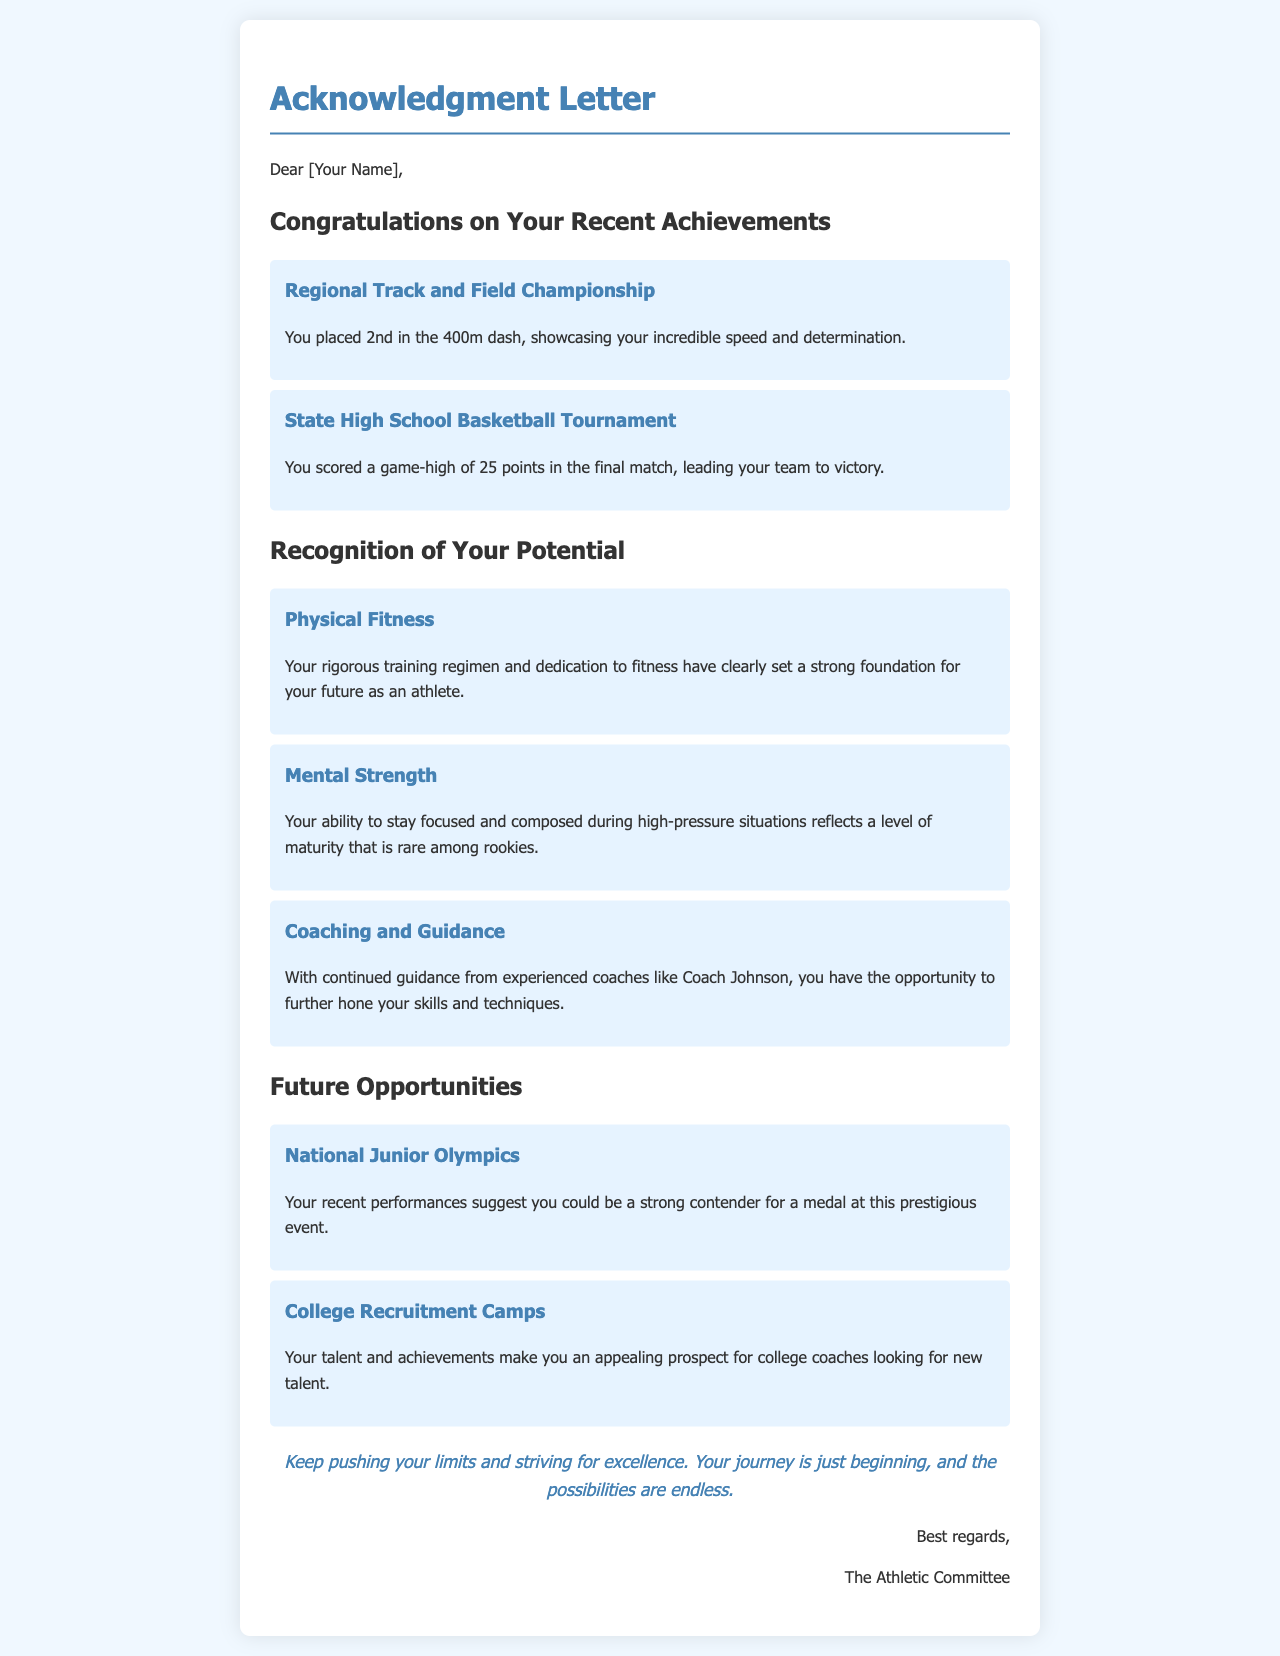What event did you place 2nd in? The document mentions the Regional Track and Field Championship where you placed 2nd.
Answer: 400m dash How many points did you score in the State High School Basketball Tournament final match? The document states you scored 25 points in the final match.
Answer: 25 points Who is mentioned as a coach providing guidance? The letter refers to Coach Johnson as an experienced coach.
Answer: Coach Johnson What is the potential event you could compete in next? The document suggests you may compete in the National Junior Olympics.
Answer: National Junior Olympics What is highlighted as a key aspect of your potential? The letter talks about your mental strength being a rare quality among rookies.
Answer: Mental Strength Which achievement leads to being an appealing prospect for college coaches? The document states your talent and achievements are what make you appealing to college coaches.
Answer: Talent and achievements What encouragement is given in the letter? The letter encourages you to keep pushing your limits and striving for excellence.
Answer: Keep pushing your limits What foundation has your training created for your future? The document mentions that your rigorous training sets a strong foundation for your future as an athlete.
Answer: Strong foundation 